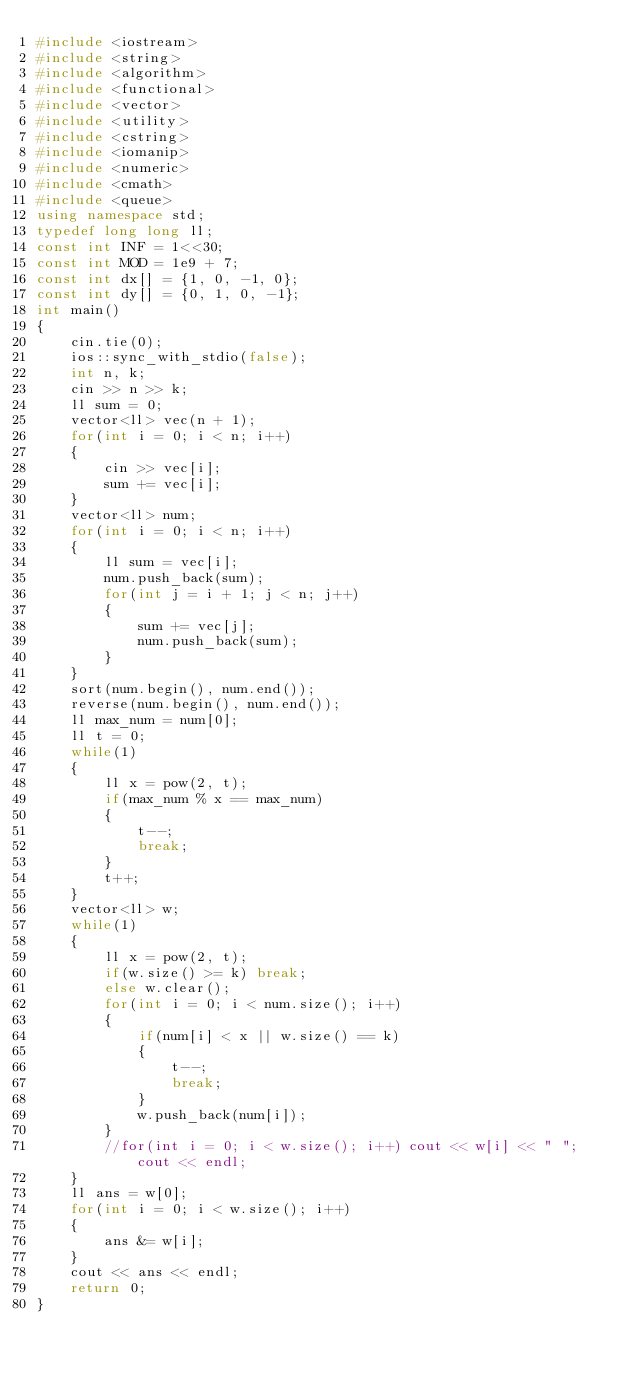Convert code to text. <code><loc_0><loc_0><loc_500><loc_500><_C++_>#include <iostream>
#include <string>
#include <algorithm>
#include <functional>
#include <vector>
#include <utility>
#include <cstring>
#include <iomanip>
#include <numeric>
#include <cmath>
#include <queue>
using namespace std;
typedef long long ll;
const int INF = 1<<30; 
const int MOD = 1e9 + 7;
const int dx[] = {1, 0, -1, 0};
const int dy[] = {0, 1, 0, -1};
int main()
{
    cin.tie(0);
    ios::sync_with_stdio(false);
    int n, k;
    cin >> n >> k;
    ll sum = 0;
    vector<ll> vec(n + 1);
    for(int i = 0; i < n; i++) 
    {
        cin >> vec[i];
        sum += vec[i];
    }
    vector<ll> num;
    for(int i = 0; i < n; i++)
    {
        ll sum = vec[i];
        num.push_back(sum);
        for(int j = i + 1; j < n; j++)
        {
            sum += vec[j];
            num.push_back(sum);
        }
    }
    sort(num.begin(), num.end());
    reverse(num.begin(), num.end());
    ll max_num = num[0];
    ll t = 0;
    while(1)
    {
        ll x = pow(2, t);
        if(max_num % x == max_num)
        {
            t--;
            break;
        }
        t++;
    }
    vector<ll> w;
    while(1)
    {
        ll x = pow(2, t);
        if(w.size() >= k) break;
        else w.clear();
        for(int i = 0; i < num.size(); i++)
        {
            if(num[i] < x || w.size() == k) 
            {
                t--;
                break;
            }
            w.push_back(num[i]);
        }
        //for(int i = 0; i < w.size(); i++) cout << w[i] << " "; cout << endl;
    }
    ll ans = w[0];
    for(int i = 0; i < w.size(); i++)
    {
        ans &= w[i];
    }
    cout << ans << endl;
    return 0;
}

</code> 